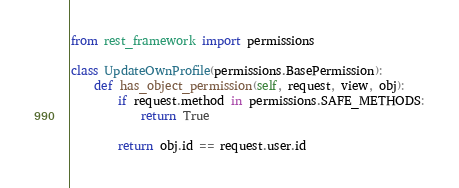Convert code to text. <code><loc_0><loc_0><loc_500><loc_500><_Python_>from rest_framework import permissions

class UpdateOwnProfile(permissions.BasePermission):
    def has_object_permission(self, request, view, obj):
        if request.method in permissions.SAFE_METHODS:
            return True

        return obj.id == request.user.id</code> 